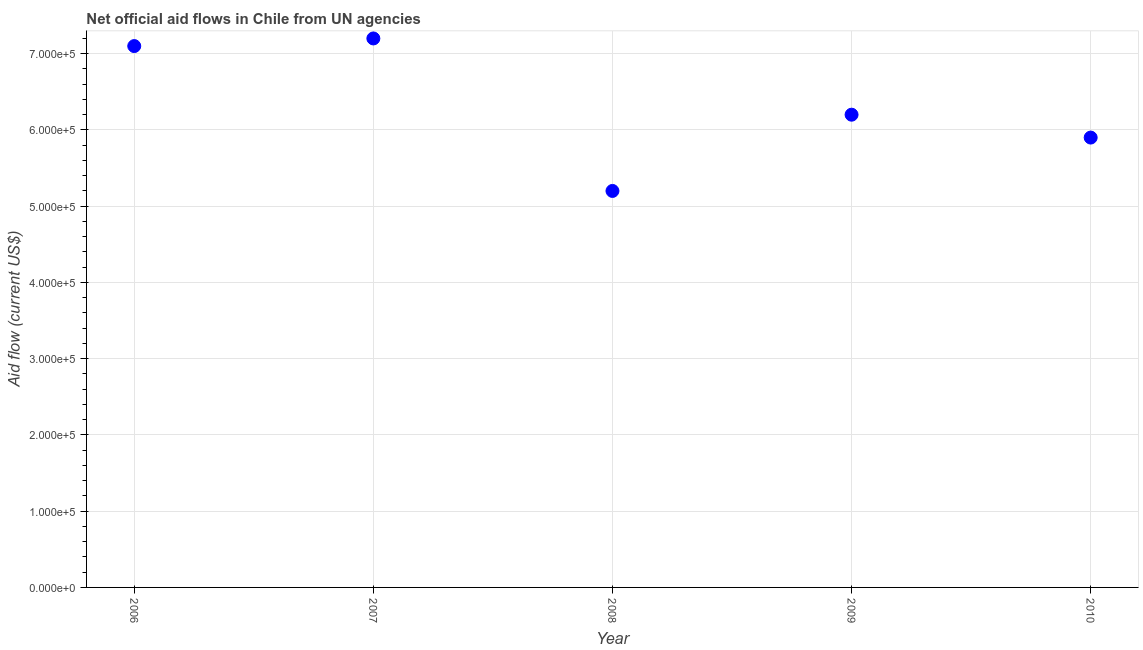What is the net official flows from un agencies in 2008?
Make the answer very short. 5.20e+05. Across all years, what is the maximum net official flows from un agencies?
Your response must be concise. 7.20e+05. Across all years, what is the minimum net official flows from un agencies?
Keep it short and to the point. 5.20e+05. In which year was the net official flows from un agencies maximum?
Your response must be concise. 2007. What is the sum of the net official flows from un agencies?
Your answer should be very brief. 3.16e+06. What is the difference between the net official flows from un agencies in 2009 and 2010?
Your response must be concise. 3.00e+04. What is the average net official flows from un agencies per year?
Your answer should be very brief. 6.32e+05. What is the median net official flows from un agencies?
Offer a very short reply. 6.20e+05. In how many years, is the net official flows from un agencies greater than 680000 US$?
Keep it short and to the point. 2. What is the ratio of the net official flows from un agencies in 2006 to that in 2007?
Your answer should be compact. 0.99. Is the net official flows from un agencies in 2007 less than that in 2009?
Provide a short and direct response. No. What is the difference between the highest and the lowest net official flows from un agencies?
Your answer should be compact. 2.00e+05. Does the net official flows from un agencies monotonically increase over the years?
Make the answer very short. No. How many dotlines are there?
Ensure brevity in your answer.  1. What is the difference between two consecutive major ticks on the Y-axis?
Offer a very short reply. 1.00e+05. Does the graph contain any zero values?
Your response must be concise. No. Does the graph contain grids?
Keep it short and to the point. Yes. What is the title of the graph?
Provide a short and direct response. Net official aid flows in Chile from UN agencies. What is the Aid flow (current US$) in 2006?
Offer a terse response. 7.10e+05. What is the Aid flow (current US$) in 2007?
Your answer should be very brief. 7.20e+05. What is the Aid flow (current US$) in 2008?
Your response must be concise. 5.20e+05. What is the Aid flow (current US$) in 2009?
Keep it short and to the point. 6.20e+05. What is the Aid flow (current US$) in 2010?
Offer a terse response. 5.90e+05. What is the difference between the Aid flow (current US$) in 2006 and 2009?
Your answer should be compact. 9.00e+04. What is the difference between the Aid flow (current US$) in 2006 and 2010?
Your answer should be very brief. 1.20e+05. What is the difference between the Aid flow (current US$) in 2007 and 2008?
Your answer should be very brief. 2.00e+05. What is the difference between the Aid flow (current US$) in 2007 and 2010?
Keep it short and to the point. 1.30e+05. What is the difference between the Aid flow (current US$) in 2008 and 2009?
Offer a terse response. -1.00e+05. What is the difference between the Aid flow (current US$) in 2008 and 2010?
Offer a terse response. -7.00e+04. What is the ratio of the Aid flow (current US$) in 2006 to that in 2007?
Provide a short and direct response. 0.99. What is the ratio of the Aid flow (current US$) in 2006 to that in 2008?
Ensure brevity in your answer.  1.36. What is the ratio of the Aid flow (current US$) in 2006 to that in 2009?
Offer a very short reply. 1.15. What is the ratio of the Aid flow (current US$) in 2006 to that in 2010?
Ensure brevity in your answer.  1.2. What is the ratio of the Aid flow (current US$) in 2007 to that in 2008?
Provide a short and direct response. 1.39. What is the ratio of the Aid flow (current US$) in 2007 to that in 2009?
Provide a short and direct response. 1.16. What is the ratio of the Aid flow (current US$) in 2007 to that in 2010?
Your answer should be very brief. 1.22. What is the ratio of the Aid flow (current US$) in 2008 to that in 2009?
Ensure brevity in your answer.  0.84. What is the ratio of the Aid flow (current US$) in 2008 to that in 2010?
Offer a terse response. 0.88. What is the ratio of the Aid flow (current US$) in 2009 to that in 2010?
Give a very brief answer. 1.05. 